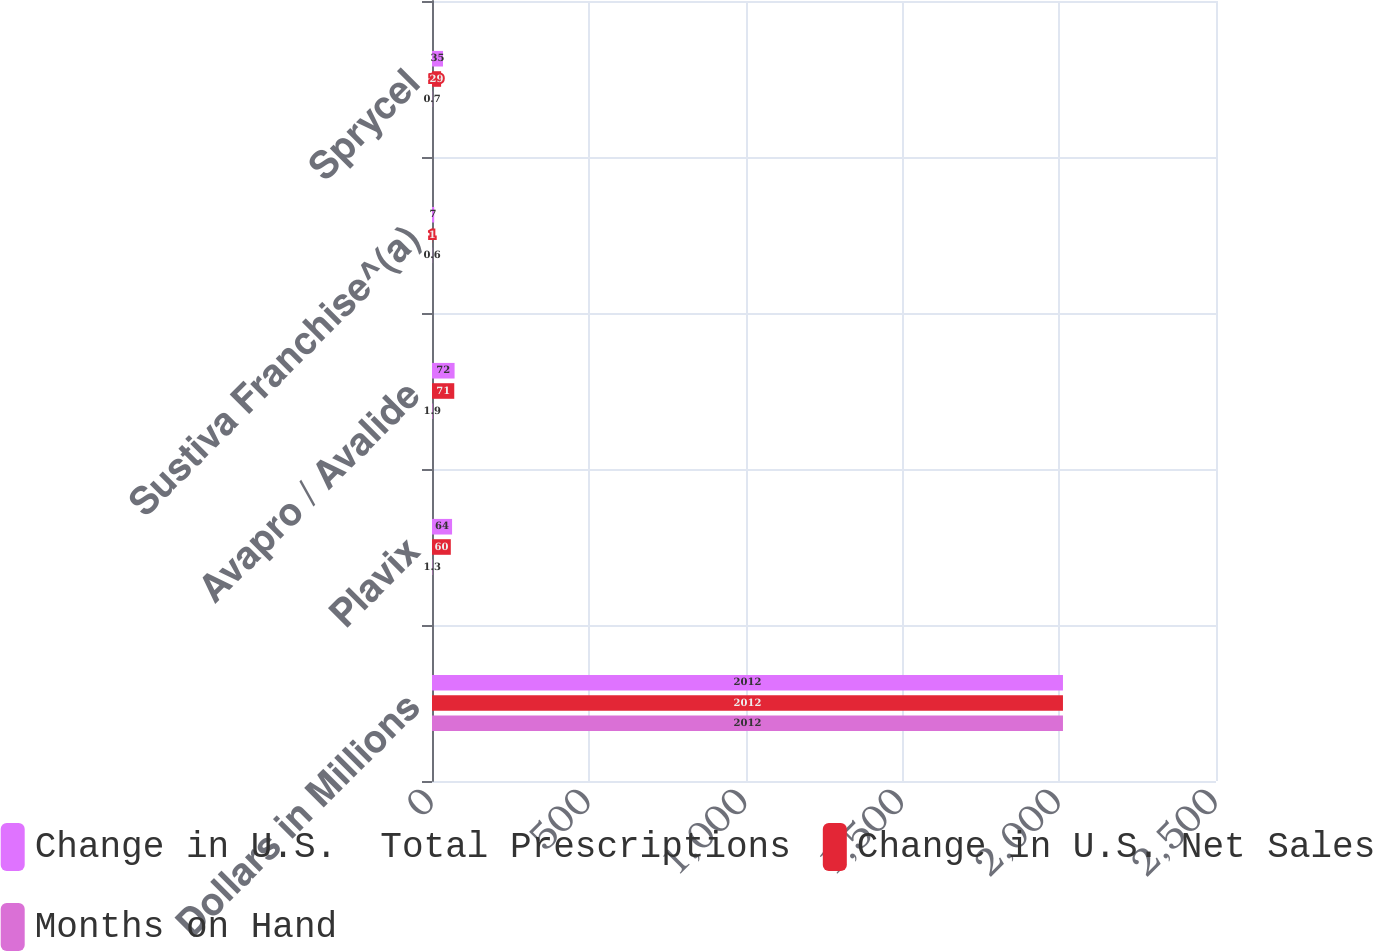<chart> <loc_0><loc_0><loc_500><loc_500><stacked_bar_chart><ecel><fcel>Dollars in Millions<fcel>Plavix<fcel>Avapro / Avalide<fcel>Sustiva Franchise^(a)<fcel>Sprycel<nl><fcel>Change in U.S.  Total Prescriptions<fcel>2012<fcel>64<fcel>72<fcel>7<fcel>35<nl><fcel>Change in U.S. Net Sales<fcel>2012<fcel>60<fcel>71<fcel>1<fcel>29<nl><fcel>Months on Hand<fcel>2012<fcel>1.3<fcel>1.9<fcel>0.6<fcel>0.7<nl></chart> 